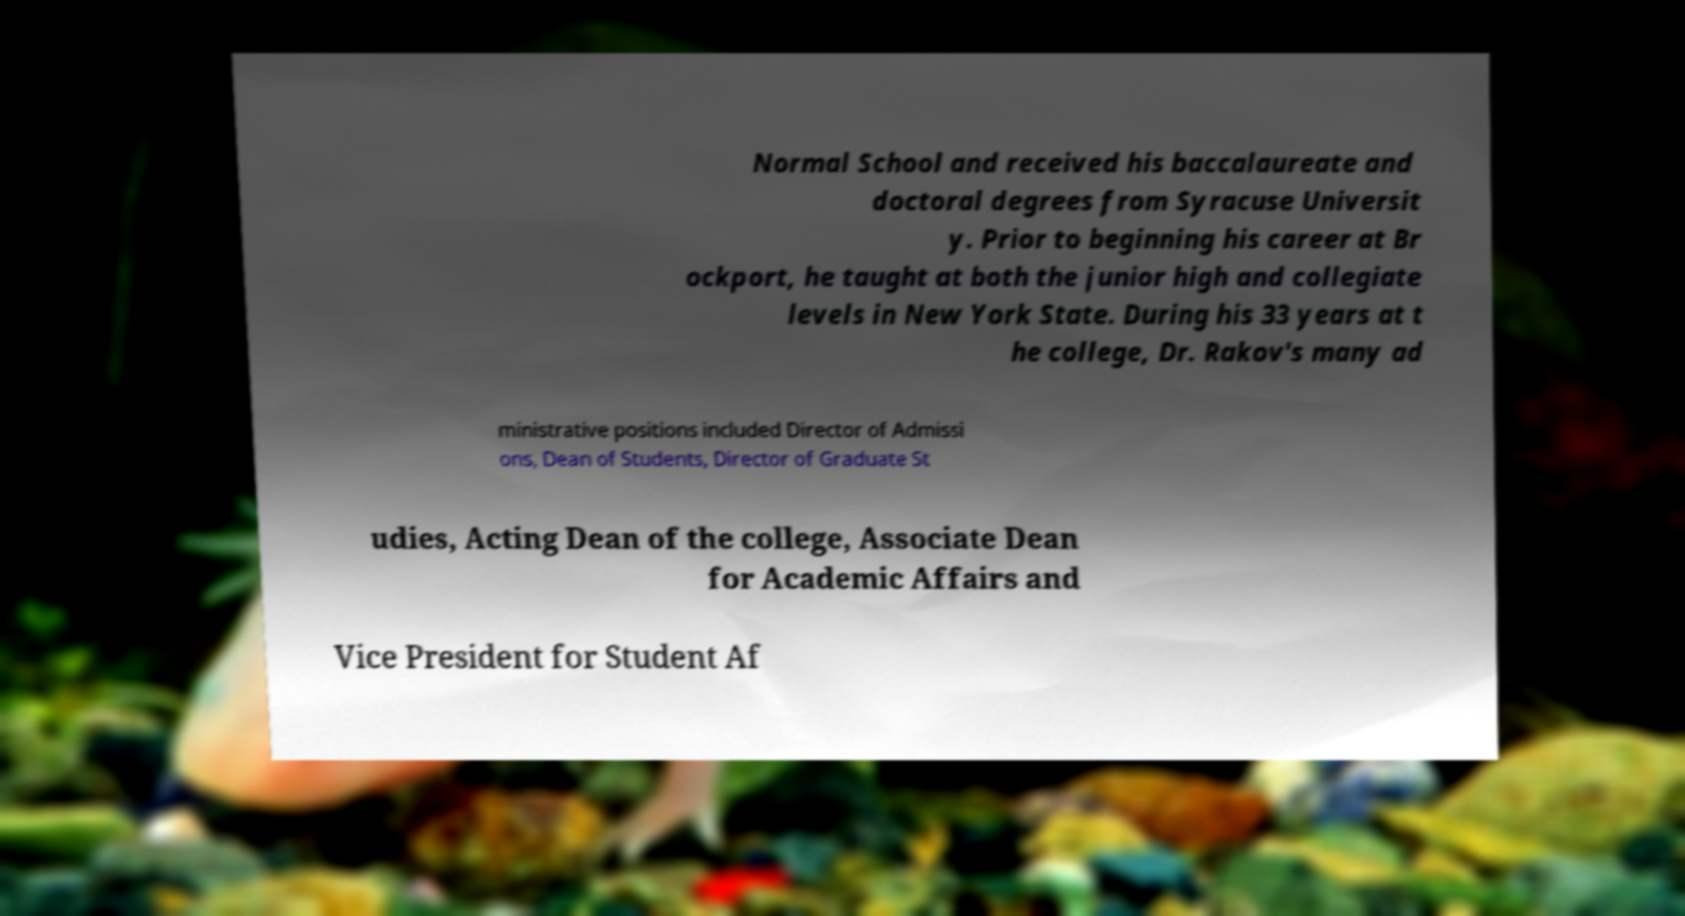I need the written content from this picture converted into text. Can you do that? Normal School and received his baccalaureate and doctoral degrees from Syracuse Universit y. Prior to beginning his career at Br ockport, he taught at both the junior high and collegiate levels in New York State. During his 33 years at t he college, Dr. Rakov's many ad ministrative positions included Director of Admissi ons, Dean of Students, Director of Graduate St udies, Acting Dean of the college, Associate Dean for Academic Affairs and Vice President for Student Af 